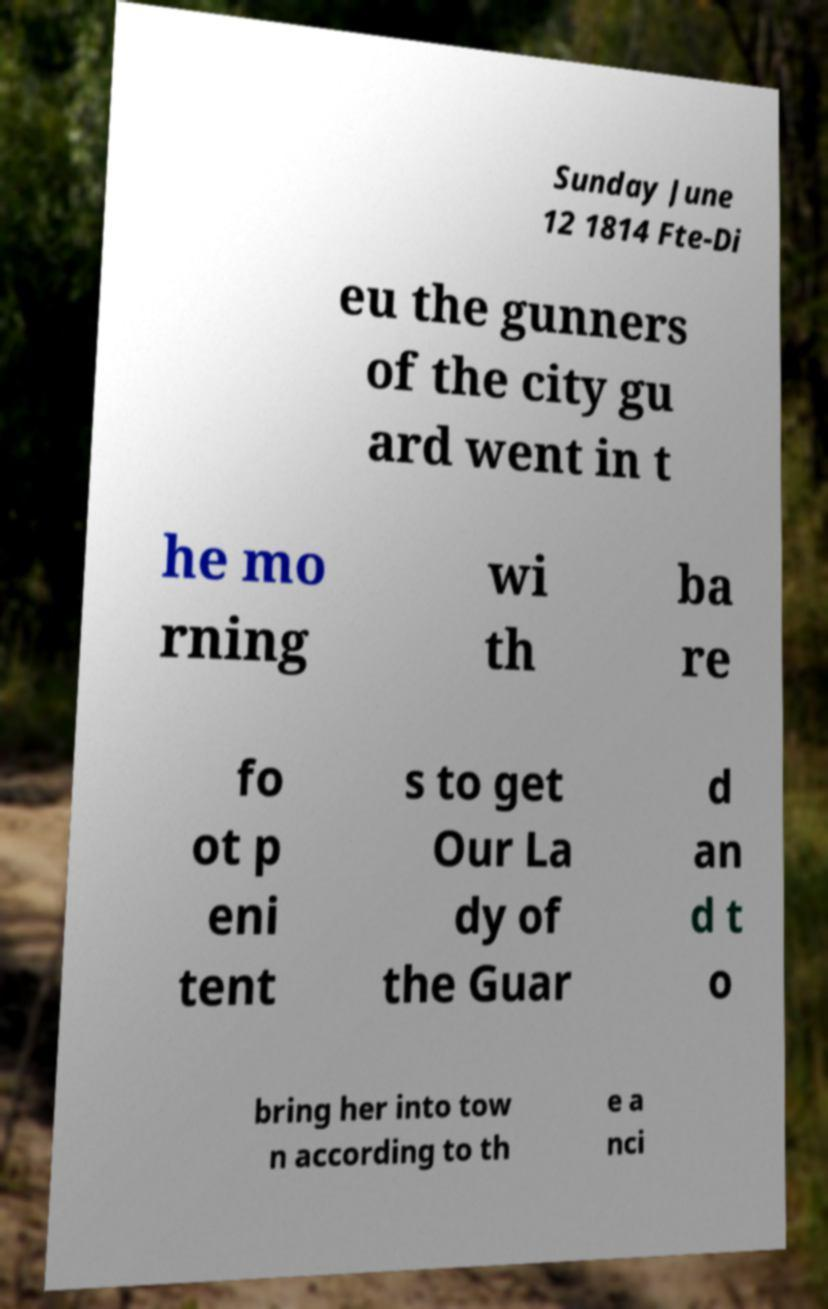Please read and relay the text visible in this image. What does it say? Sunday June 12 1814 Fte-Di eu the gunners of the city gu ard went in t he mo rning wi th ba re fo ot p eni tent s to get Our La dy of the Guar d an d t o bring her into tow n according to th e a nci 